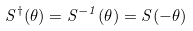Convert formula to latex. <formula><loc_0><loc_0><loc_500><loc_500>S ^ { \dagger } ( \theta ) = S ^ { - 1 } ( \theta ) = S ( - \theta )</formula> 